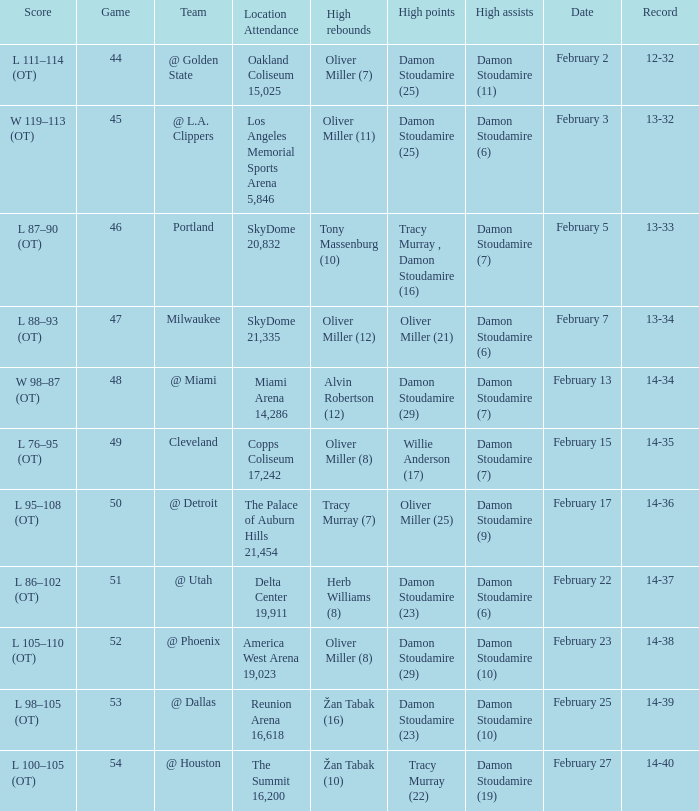How many locations have a record of 14-38? 1.0. 